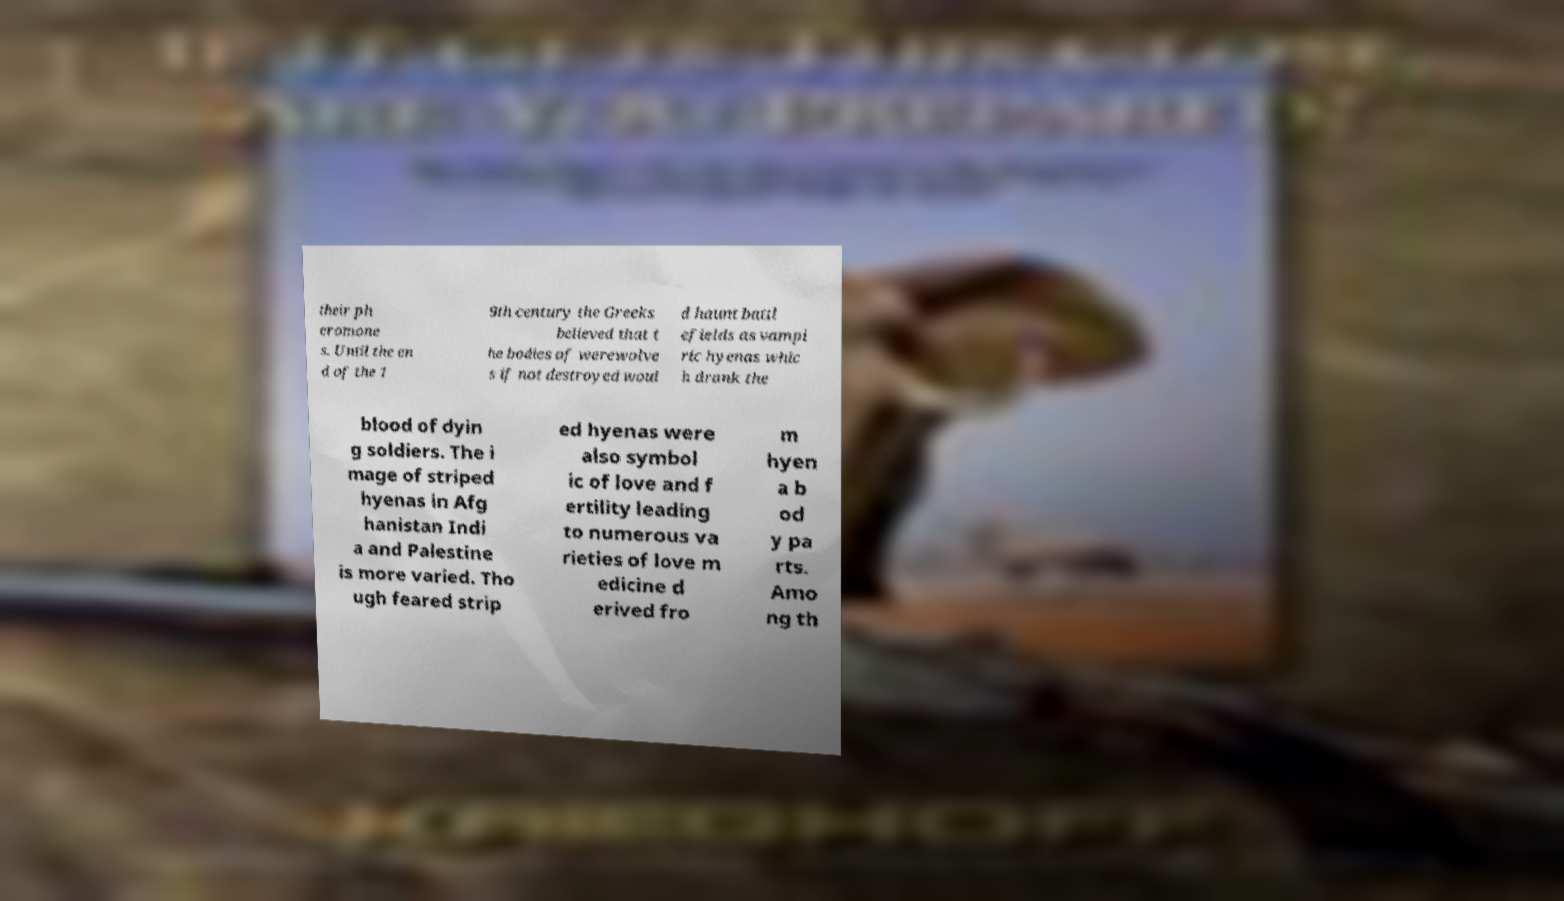Can you read and provide the text displayed in the image?This photo seems to have some interesting text. Can you extract and type it out for me? their ph eromone s. Until the en d of the 1 9th century the Greeks believed that t he bodies of werewolve s if not destroyed woul d haunt battl efields as vampi ric hyenas whic h drank the blood of dyin g soldiers. The i mage of striped hyenas in Afg hanistan Indi a and Palestine is more varied. Tho ugh feared strip ed hyenas were also symbol ic of love and f ertility leading to numerous va rieties of love m edicine d erived fro m hyen a b od y pa rts. Amo ng th 